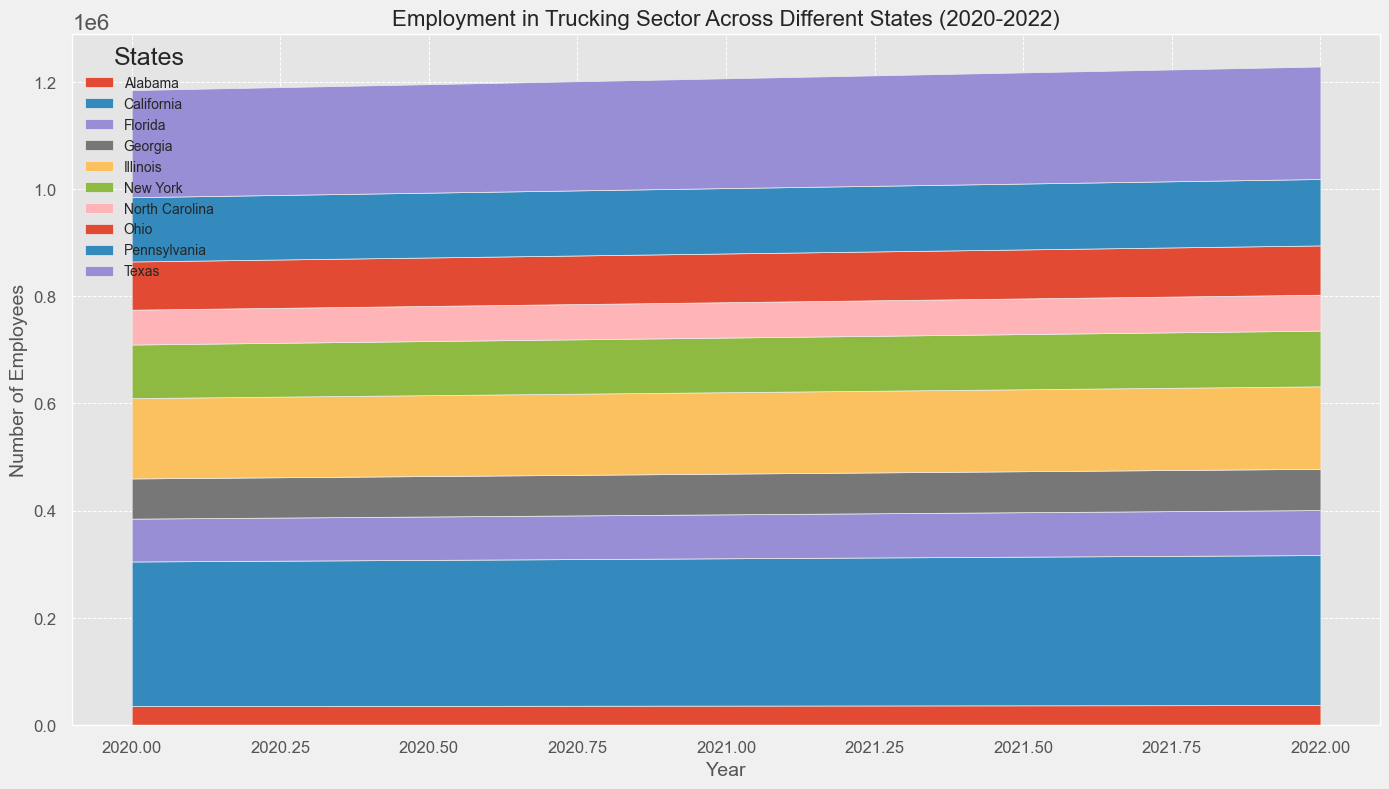What was the total employment in the trucking sector across all states in 2022? Add up employment figures for each state in 2022: Alabama (37000) + California (280000) + Florida (84000) + Illinois (154000) + Texas (210000) + New York (104000) + Pennsylvania (124000) + Ohio (92000) + Georgia (77000) + North Carolina (67000) = 1173000
Answer: 1173000 Which state had the highest employment in the trucking sector in 2021? Compare the employment figures across all states for 2021: Alabama (36000), California (275000), Florida (82000), Illinois (152000), Texas (205000), New York (102000), Pennsylvania (122000), Ohio (91000), Georgia (76000), North Carolina (66000). The highest is California with 275000.
Answer: California How did Texas' employment in 2022 compare to its employment in 2020? Texas' employment in 2022 was 210000 and in 2020 it was 200000. The difference is 210000 - 200000 = 10000
Answer: 10000 What is the average wage for truck drivers across all states in 2022? Add up wages for each state in 2022 and divide by the number of states: (47000+54000+44000+50000+52000+49000+48000+46000+45000+44000) / 10 = 474000 / 10 = 47400
Answer: 47400 Which state had the greatest increase in employment from 2020 to 2022? Calculate the change for each state from 2020 to 2022 and identify the greatest increase: Alabama (37000-35000=2000), California (280000-270000=10000), Florida (84000-80000=4000), Illinois (154000-150000=4000), Texas (210000-200000=10000), New York (104000-100000=4000), Pennsylvania (124000-120000=4000), Ohio (92000-90000=2000), Georgia (77000-75000=2000), North Carolina (67000-65000=2000). Both California and Texas had the greatest increase of 10000.
Answer: California, Texas Which state had the lowest average wage growth between 2020 and 2022? Calculate the wage growth for each state from 2020 to 2022 and find the lowest: Alabama (47000-45000=2000), California (54000-52000=2000), Florida (44000-42000=2000), Illinois (50000-48000=2000), Texas (52000-50000=2000), New York (49000-47000=2000), Pennsylvania (48000-46000=2000), Ohio (46000-44000=2000), Georgia (45000-43000=2000), North Carolina (44000-42000=2000). All states had the same wage growth of 2000.
Answer: All states What visual trend do you observe in employment figures from 2020 to 2022 across the states? Employment figures show a general increasing trend across all states from 2020 to 2022.
Answer: Increasing trend Comparing the employment numbers, which state showed the least amount of change between 2020 and 2022? Calculate change for each state: Alabama (2000), California (10000), Florida (4000), Illinois (4000), Texas (10000), New York (4000), Pennsylvania (4000), Ohio (2000), Georgia (2000), North Carolina (2000). The least amount of change was in Alabama, Ohio, Georgia, and North Carolina with 2000.
Answer: Alabama, Ohio, Georgia, North Carolina How did the employment figures for Pennsylvania in 2021 compare to Ohio in 2021? Pennsylvania's employment in 2021 was 122000 and Ohio's was 91000. The difference is 122000 - 91000 = 31000. Pennsylvania had 31000 more than Ohio.
Answer: 31000 